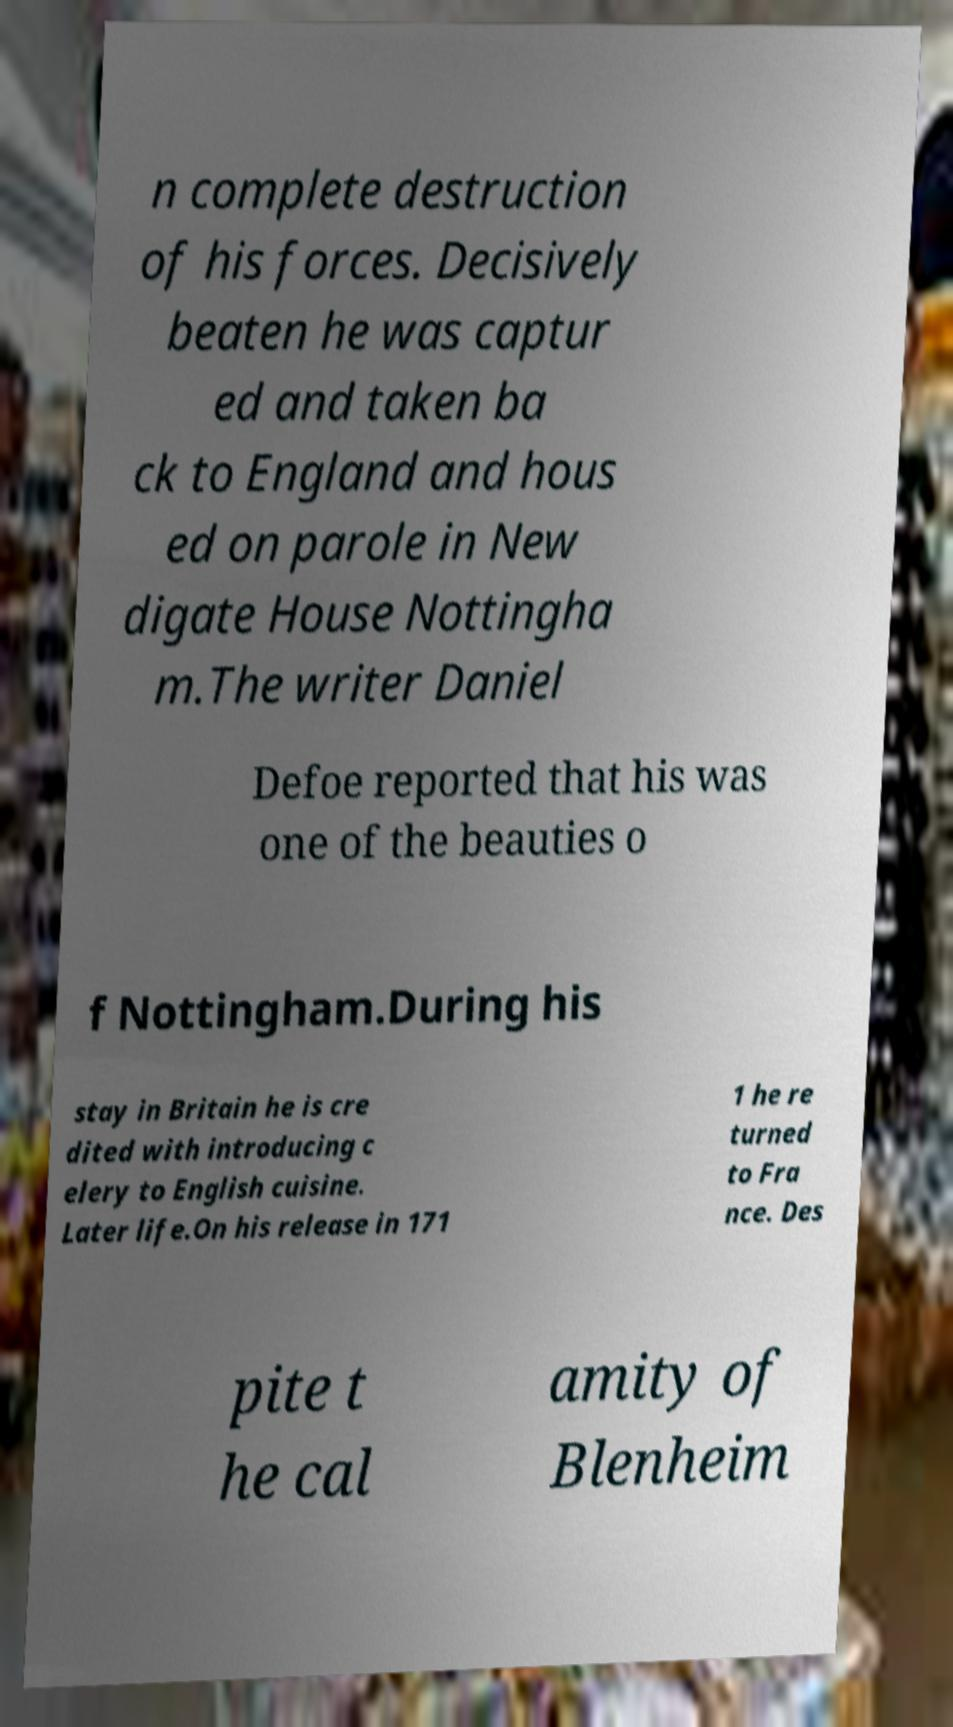Can you read and provide the text displayed in the image?This photo seems to have some interesting text. Can you extract and type it out for me? n complete destruction of his forces. Decisively beaten he was captur ed and taken ba ck to England and hous ed on parole in New digate House Nottingha m.The writer Daniel Defoe reported that his was one of the beauties o f Nottingham.During his stay in Britain he is cre dited with introducing c elery to English cuisine. Later life.On his release in 171 1 he re turned to Fra nce. Des pite t he cal amity of Blenheim 